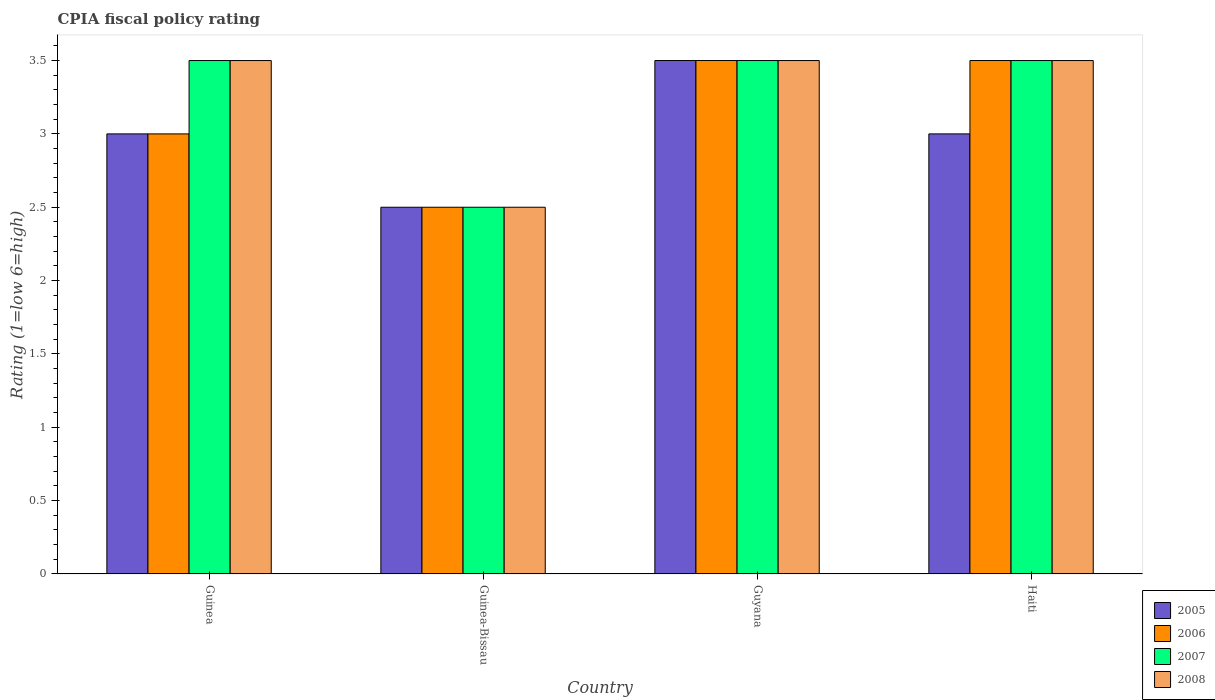How many different coloured bars are there?
Offer a very short reply. 4. How many groups of bars are there?
Keep it short and to the point. 4. How many bars are there on the 2nd tick from the right?
Keep it short and to the point. 4. What is the label of the 3rd group of bars from the left?
Make the answer very short. Guyana. In how many cases, is the number of bars for a given country not equal to the number of legend labels?
Keep it short and to the point. 0. What is the CPIA rating in 2005 in Guyana?
Provide a short and direct response. 3.5. In which country was the CPIA rating in 2005 maximum?
Offer a very short reply. Guyana. In which country was the CPIA rating in 2005 minimum?
Offer a terse response. Guinea-Bissau. What is the total CPIA rating in 2007 in the graph?
Your answer should be very brief. 13. What is the difference between the CPIA rating in 2006 in Guyana and that in Haiti?
Ensure brevity in your answer.  0. What is the average CPIA rating in 2008 per country?
Your response must be concise. 3.25. What is the difference between the CPIA rating of/in 2007 and CPIA rating of/in 2008 in Guyana?
Offer a terse response. 0. In how many countries, is the CPIA rating in 2008 greater than 2.9?
Keep it short and to the point. 3. What is the ratio of the CPIA rating in 2008 in Guinea to that in Haiti?
Give a very brief answer. 1. What does the 2nd bar from the right in Guinea represents?
Keep it short and to the point. 2007. Is it the case that in every country, the sum of the CPIA rating in 2005 and CPIA rating in 2007 is greater than the CPIA rating in 2006?
Provide a succinct answer. Yes. What is the difference between two consecutive major ticks on the Y-axis?
Offer a terse response. 0.5. Does the graph contain grids?
Give a very brief answer. No. Where does the legend appear in the graph?
Ensure brevity in your answer.  Bottom right. What is the title of the graph?
Give a very brief answer. CPIA fiscal policy rating. What is the label or title of the X-axis?
Your response must be concise. Country. What is the label or title of the Y-axis?
Offer a very short reply. Rating (1=low 6=high). What is the Rating (1=low 6=high) of 2007 in Guinea?
Your response must be concise. 3.5. What is the Rating (1=low 6=high) of 2008 in Guinea?
Your answer should be very brief. 3.5. What is the Rating (1=low 6=high) in 2005 in Guinea-Bissau?
Your response must be concise. 2.5. What is the Rating (1=low 6=high) in 2006 in Guinea-Bissau?
Provide a short and direct response. 2.5. What is the Rating (1=low 6=high) in 2008 in Guinea-Bissau?
Give a very brief answer. 2.5. What is the Rating (1=low 6=high) in 2007 in Guyana?
Provide a short and direct response. 3.5. Across all countries, what is the maximum Rating (1=low 6=high) of 2006?
Provide a short and direct response. 3.5. Across all countries, what is the maximum Rating (1=low 6=high) in 2008?
Offer a terse response. 3.5. Across all countries, what is the minimum Rating (1=low 6=high) of 2006?
Offer a terse response. 2.5. Across all countries, what is the minimum Rating (1=low 6=high) of 2008?
Provide a succinct answer. 2.5. What is the total Rating (1=low 6=high) in 2005 in the graph?
Your answer should be very brief. 12. What is the total Rating (1=low 6=high) in 2006 in the graph?
Ensure brevity in your answer.  12.5. What is the total Rating (1=low 6=high) of 2007 in the graph?
Your answer should be compact. 13. What is the total Rating (1=low 6=high) of 2008 in the graph?
Ensure brevity in your answer.  13. What is the difference between the Rating (1=low 6=high) of 2005 in Guinea and that in Guinea-Bissau?
Your answer should be compact. 0.5. What is the difference between the Rating (1=low 6=high) in 2005 in Guinea and that in Guyana?
Keep it short and to the point. -0.5. What is the difference between the Rating (1=low 6=high) in 2006 in Guinea and that in Guyana?
Offer a terse response. -0.5. What is the difference between the Rating (1=low 6=high) in 2008 in Guinea and that in Guyana?
Offer a terse response. 0. What is the difference between the Rating (1=low 6=high) of 2005 in Guinea and that in Haiti?
Your answer should be compact. 0. What is the difference between the Rating (1=low 6=high) of 2008 in Guinea and that in Haiti?
Keep it short and to the point. 0. What is the difference between the Rating (1=low 6=high) in 2006 in Guinea-Bissau and that in Haiti?
Your answer should be very brief. -1. What is the difference between the Rating (1=low 6=high) in 2007 in Guinea-Bissau and that in Haiti?
Make the answer very short. -1. What is the difference between the Rating (1=low 6=high) in 2005 in Guyana and that in Haiti?
Your answer should be very brief. 0.5. What is the difference between the Rating (1=low 6=high) of 2007 in Guyana and that in Haiti?
Provide a short and direct response. 0. What is the difference between the Rating (1=low 6=high) of 2005 in Guinea and the Rating (1=low 6=high) of 2006 in Guinea-Bissau?
Provide a short and direct response. 0.5. What is the difference between the Rating (1=low 6=high) in 2005 in Guinea and the Rating (1=low 6=high) in 2007 in Guinea-Bissau?
Keep it short and to the point. 0.5. What is the difference between the Rating (1=low 6=high) of 2005 in Guinea and the Rating (1=low 6=high) of 2008 in Guinea-Bissau?
Give a very brief answer. 0.5. What is the difference between the Rating (1=low 6=high) in 2005 in Guinea and the Rating (1=low 6=high) in 2006 in Guyana?
Provide a succinct answer. -0.5. What is the difference between the Rating (1=low 6=high) of 2005 in Guinea and the Rating (1=low 6=high) of 2007 in Guyana?
Ensure brevity in your answer.  -0.5. What is the difference between the Rating (1=low 6=high) of 2006 in Guinea and the Rating (1=low 6=high) of 2007 in Guyana?
Your answer should be compact. -0.5. What is the difference between the Rating (1=low 6=high) in 2005 in Guinea and the Rating (1=low 6=high) in 2007 in Haiti?
Offer a terse response. -0.5. What is the difference between the Rating (1=low 6=high) of 2005 in Guinea and the Rating (1=low 6=high) of 2008 in Haiti?
Keep it short and to the point. -0.5. What is the difference between the Rating (1=low 6=high) in 2006 in Guinea and the Rating (1=low 6=high) in 2007 in Haiti?
Your answer should be very brief. -0.5. What is the difference between the Rating (1=low 6=high) of 2007 in Guinea and the Rating (1=low 6=high) of 2008 in Haiti?
Your answer should be very brief. 0. What is the difference between the Rating (1=low 6=high) of 2005 in Guinea-Bissau and the Rating (1=low 6=high) of 2007 in Guyana?
Offer a very short reply. -1. What is the difference between the Rating (1=low 6=high) of 2005 in Guinea-Bissau and the Rating (1=low 6=high) of 2008 in Guyana?
Your response must be concise. -1. What is the difference between the Rating (1=low 6=high) of 2006 in Guinea-Bissau and the Rating (1=low 6=high) of 2008 in Guyana?
Offer a very short reply. -1. What is the difference between the Rating (1=low 6=high) of 2007 in Guinea-Bissau and the Rating (1=low 6=high) of 2008 in Guyana?
Your answer should be compact. -1. What is the difference between the Rating (1=low 6=high) of 2005 in Guinea-Bissau and the Rating (1=low 6=high) of 2006 in Haiti?
Your answer should be compact. -1. What is the difference between the Rating (1=low 6=high) of 2005 in Guinea-Bissau and the Rating (1=low 6=high) of 2007 in Haiti?
Provide a short and direct response. -1. What is the difference between the Rating (1=low 6=high) of 2005 in Guinea-Bissau and the Rating (1=low 6=high) of 2008 in Haiti?
Offer a terse response. -1. What is the difference between the Rating (1=low 6=high) of 2006 in Guinea-Bissau and the Rating (1=low 6=high) of 2007 in Haiti?
Ensure brevity in your answer.  -1. What is the difference between the Rating (1=low 6=high) in 2006 in Guinea-Bissau and the Rating (1=low 6=high) in 2008 in Haiti?
Make the answer very short. -1. What is the difference between the Rating (1=low 6=high) in 2005 in Guyana and the Rating (1=low 6=high) in 2006 in Haiti?
Keep it short and to the point. 0. What is the average Rating (1=low 6=high) in 2006 per country?
Provide a succinct answer. 3.12. What is the average Rating (1=low 6=high) of 2007 per country?
Offer a terse response. 3.25. What is the average Rating (1=low 6=high) in 2008 per country?
Provide a short and direct response. 3.25. What is the difference between the Rating (1=low 6=high) in 2006 and Rating (1=low 6=high) in 2007 in Guinea?
Your answer should be compact. -0.5. What is the difference between the Rating (1=low 6=high) in 2006 and Rating (1=low 6=high) in 2008 in Guinea?
Your answer should be compact. -0.5. What is the difference between the Rating (1=low 6=high) of 2005 and Rating (1=low 6=high) of 2007 in Guinea-Bissau?
Keep it short and to the point. 0. What is the difference between the Rating (1=low 6=high) in 2005 and Rating (1=low 6=high) in 2008 in Guinea-Bissau?
Ensure brevity in your answer.  0. What is the difference between the Rating (1=low 6=high) of 2007 and Rating (1=low 6=high) of 2008 in Guinea-Bissau?
Offer a terse response. 0. What is the difference between the Rating (1=low 6=high) in 2005 and Rating (1=low 6=high) in 2008 in Guyana?
Your response must be concise. 0. What is the difference between the Rating (1=low 6=high) of 2005 and Rating (1=low 6=high) of 2007 in Haiti?
Keep it short and to the point. -0.5. What is the ratio of the Rating (1=low 6=high) of 2007 in Guinea to that in Guinea-Bissau?
Give a very brief answer. 1.4. What is the ratio of the Rating (1=low 6=high) in 2005 in Guinea to that in Guyana?
Offer a terse response. 0.86. What is the ratio of the Rating (1=low 6=high) of 2006 in Guinea to that in Guyana?
Your answer should be compact. 0.86. What is the ratio of the Rating (1=low 6=high) of 2008 in Guinea to that in Guyana?
Ensure brevity in your answer.  1. What is the ratio of the Rating (1=low 6=high) in 2006 in Guinea to that in Haiti?
Your answer should be very brief. 0.86. What is the ratio of the Rating (1=low 6=high) of 2005 in Guinea-Bissau to that in Guyana?
Your answer should be very brief. 0.71. What is the ratio of the Rating (1=low 6=high) in 2006 in Guinea-Bissau to that in Guyana?
Offer a very short reply. 0.71. What is the ratio of the Rating (1=low 6=high) of 2007 in Guinea-Bissau to that in Guyana?
Your response must be concise. 0.71. What is the ratio of the Rating (1=low 6=high) of 2008 in Guinea-Bissau to that in Guyana?
Provide a short and direct response. 0.71. What is the ratio of the Rating (1=low 6=high) of 2006 in Guinea-Bissau to that in Haiti?
Your answer should be compact. 0.71. What is the ratio of the Rating (1=low 6=high) of 2008 in Guinea-Bissau to that in Haiti?
Ensure brevity in your answer.  0.71. What is the ratio of the Rating (1=low 6=high) of 2005 in Guyana to that in Haiti?
Your response must be concise. 1.17. What is the ratio of the Rating (1=low 6=high) of 2006 in Guyana to that in Haiti?
Your response must be concise. 1. What is the ratio of the Rating (1=low 6=high) in 2007 in Guyana to that in Haiti?
Give a very brief answer. 1. What is the ratio of the Rating (1=low 6=high) of 2008 in Guyana to that in Haiti?
Your response must be concise. 1. What is the difference between the highest and the second highest Rating (1=low 6=high) of 2005?
Make the answer very short. 0.5. What is the difference between the highest and the second highest Rating (1=low 6=high) of 2007?
Offer a very short reply. 0. What is the difference between the highest and the lowest Rating (1=low 6=high) of 2005?
Make the answer very short. 1. What is the difference between the highest and the lowest Rating (1=low 6=high) of 2007?
Offer a very short reply. 1. What is the difference between the highest and the lowest Rating (1=low 6=high) in 2008?
Provide a short and direct response. 1. 